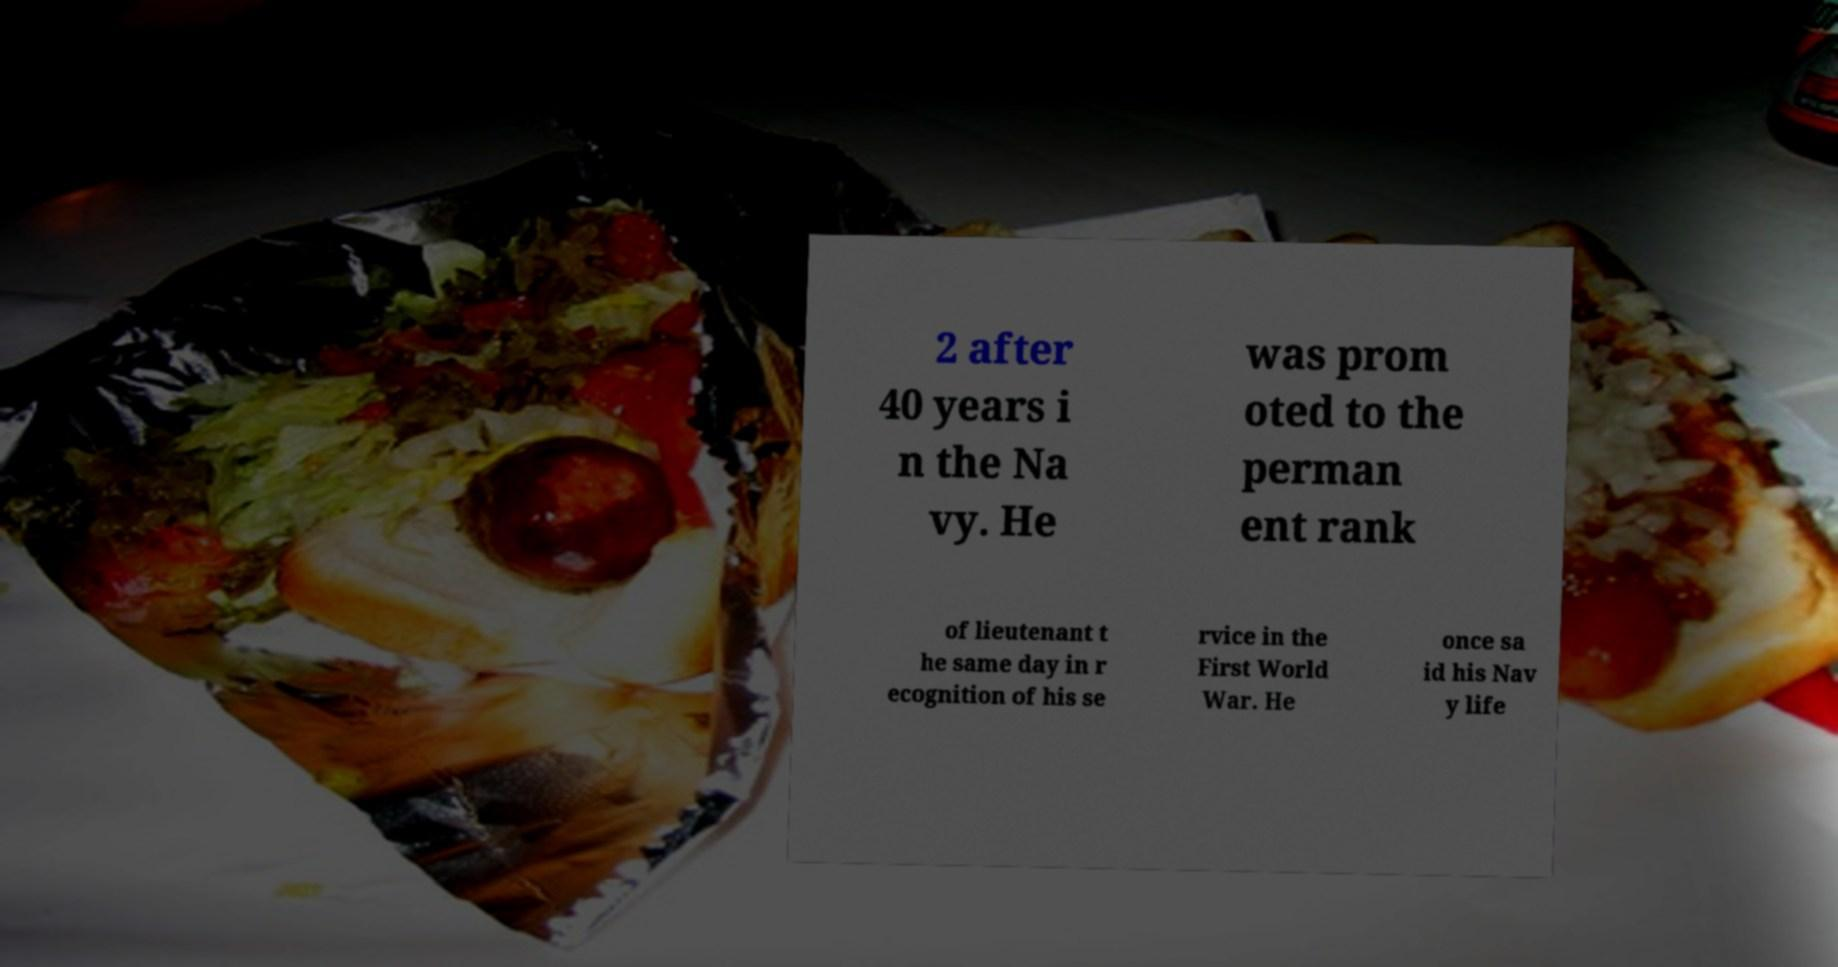What messages or text are displayed in this image? I need them in a readable, typed format. 2 after 40 years i n the Na vy. He was prom oted to the perman ent rank of lieutenant t he same day in r ecognition of his se rvice in the First World War. He once sa id his Nav y life 